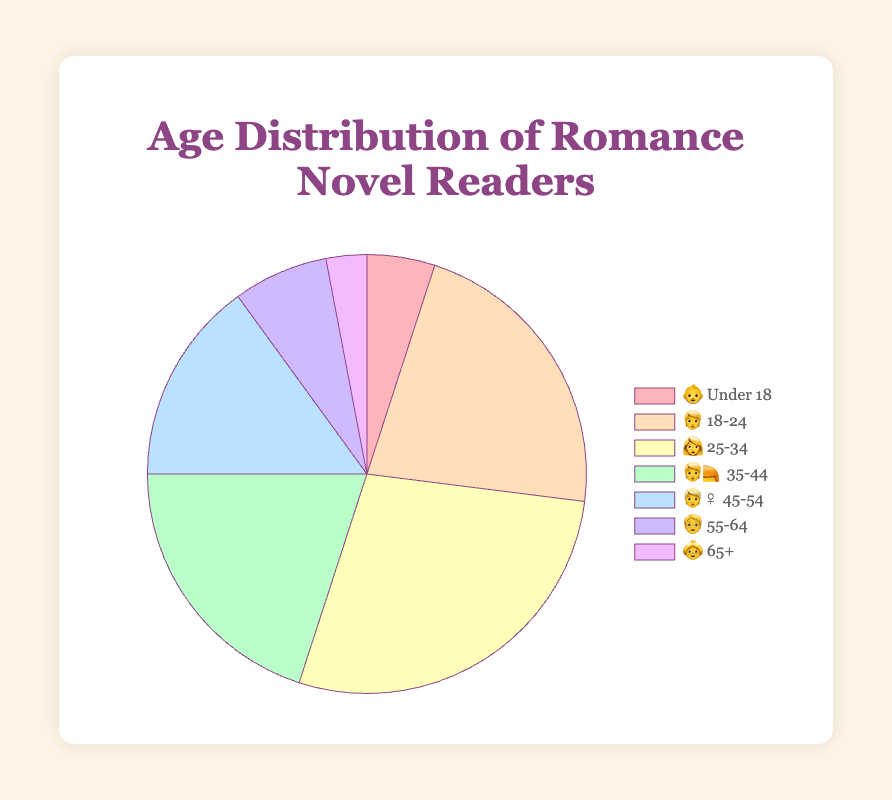Which age group has the highest percentage of romance novel readers? The `👩 25-34` age group has 28%, which is the highest listed percentage among all age groups.
Answer: `👩 25-34` age group with 28% What is the total percentage of romance novel readers aged 45 and older? Add the percentages for the age groups `👱‍♀️ 45-54` (15%), `🧓 55-64` (7%), and `👵 65+` (3%): 15 + 7 + 3 = 25%.
Answer: 25% Which two age groups combined have a higher percentage than the `👩 25-34` age group alone? The `🧑 18-24` age group (22%) and the `👶 Under 18` age group (5%) combined have a percentage of 22 + 5 = 27%, which is less than 28%. However, the `🧑‍🦰 35-44` age group (20%) and the `🧑 18-24` age group (22%) combined have a percentage of 20 + 22 = 42%, which is higher than 28%.
Answer: `🧑 18-24` and `🧑‍🦰 35-44` combined with 42% What is the percentage difference between the youngest and oldest age groups of readers? The `👶 Under 18` age group has 5%, and the `👵 65+` age group has 3%. The difference is 5 - 3 = 2%.
Answer: 2% How much more popular is the `👩 25-34` age group compared to the `🧓 55-64` age group? The `👩 25-34` group has 28% and the `🧓 55-64` group has 7%. The difference is 28 - 7 = 21%.
Answer: 21% Is there an age group that represents exactly one-fifth of the romance novel reading population? Check each percentage. One-fifth is equal to 20%. The `🧑‍🦰 35-44` age group is at 20%.
Answer: Yes, `🧑‍🦰 35-44` Which age group has the smallest representation among romance novel readers? The `👵 65+` age group has the smallest percentage at 3%.
Answer: `👵 65+` age group with 3% What is the average percentage of the age groups `👶 Under 18`, `🧑 18-24`, and `👩 25-34`? Add the percentages for `👶 Under 18` (5%), `🧑 18-24` (22%), and `👩 25-34` (28%): 5 + 22 + 28 = 55%. Then, divide by 3: 55 / 3 ≈ 18.33%.
Answer: 18.33% What combined percentage do the age groups `👶 Under 18` and `👱‍♀️ 45-54` represent? Add percentages of `👶 Under 18` (5%) and `👱‍♀️ 45-54` (15%): 5 + 15 = 20%.
Answer: 20% 